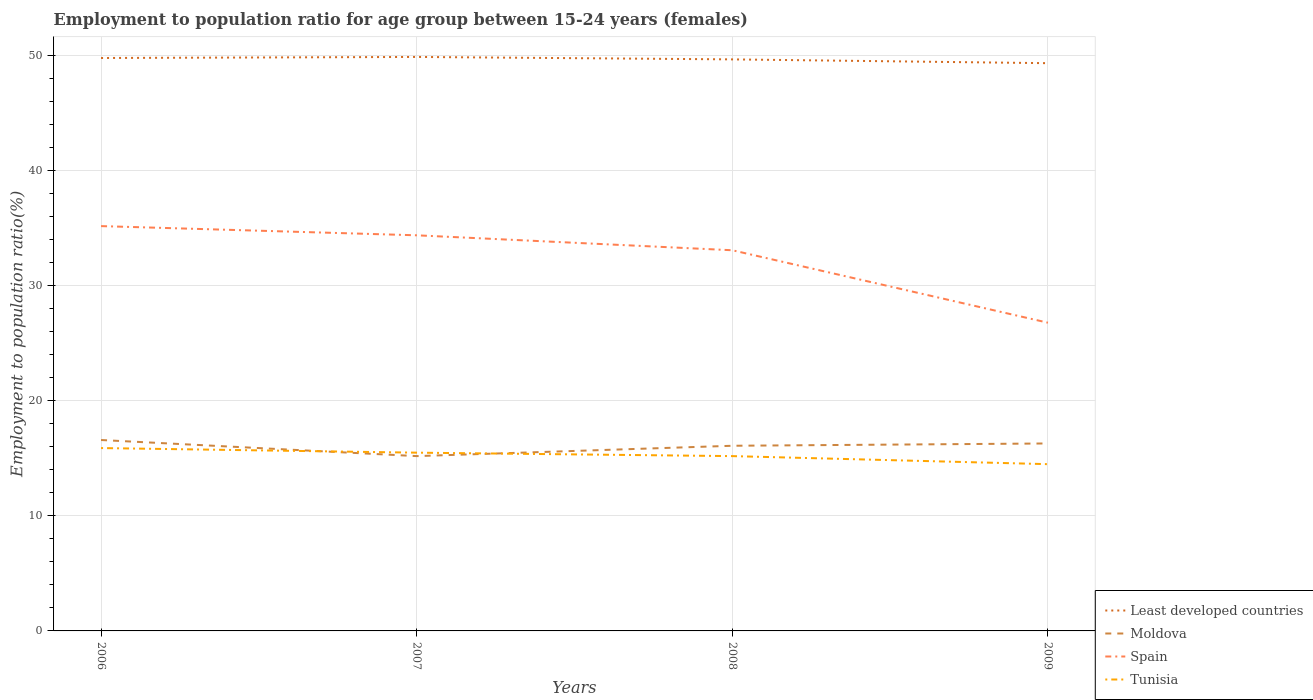Does the line corresponding to Spain intersect with the line corresponding to Tunisia?
Offer a very short reply. No. Is the number of lines equal to the number of legend labels?
Offer a very short reply. Yes. Across all years, what is the maximum employment to population ratio in Spain?
Provide a succinct answer. 26.8. What is the total employment to population ratio in Least developed countries in the graph?
Give a very brief answer. 0.45. What is the difference between the highest and the second highest employment to population ratio in Moldova?
Give a very brief answer. 1.4. What is the difference between the highest and the lowest employment to population ratio in Moldova?
Your response must be concise. 3. Is the employment to population ratio in Tunisia strictly greater than the employment to population ratio in Spain over the years?
Your answer should be very brief. Yes. How many lines are there?
Ensure brevity in your answer.  4. How many years are there in the graph?
Provide a short and direct response. 4. Are the values on the major ticks of Y-axis written in scientific E-notation?
Give a very brief answer. No. Does the graph contain any zero values?
Offer a terse response. No. Does the graph contain grids?
Offer a very short reply. Yes. What is the title of the graph?
Your answer should be very brief. Employment to population ratio for age group between 15-24 years (females). Does "OECD members" appear as one of the legend labels in the graph?
Offer a very short reply. No. What is the label or title of the X-axis?
Your answer should be very brief. Years. What is the label or title of the Y-axis?
Your answer should be compact. Employment to population ratio(%). What is the Employment to population ratio(%) of Least developed countries in 2006?
Keep it short and to the point. 49.82. What is the Employment to population ratio(%) of Moldova in 2006?
Make the answer very short. 16.6. What is the Employment to population ratio(%) in Spain in 2006?
Offer a very short reply. 35.2. What is the Employment to population ratio(%) of Tunisia in 2006?
Your response must be concise. 15.9. What is the Employment to population ratio(%) in Least developed countries in 2007?
Provide a short and direct response. 49.91. What is the Employment to population ratio(%) of Moldova in 2007?
Make the answer very short. 15.2. What is the Employment to population ratio(%) in Spain in 2007?
Your answer should be very brief. 34.4. What is the Employment to population ratio(%) of Tunisia in 2007?
Your answer should be very brief. 15.5. What is the Employment to population ratio(%) of Least developed countries in 2008?
Your answer should be compact. 49.7. What is the Employment to population ratio(%) of Moldova in 2008?
Your response must be concise. 16.1. What is the Employment to population ratio(%) of Spain in 2008?
Your answer should be very brief. 33.1. What is the Employment to population ratio(%) of Tunisia in 2008?
Give a very brief answer. 15.2. What is the Employment to population ratio(%) in Least developed countries in 2009?
Ensure brevity in your answer.  49.37. What is the Employment to population ratio(%) in Moldova in 2009?
Offer a terse response. 16.3. What is the Employment to population ratio(%) of Spain in 2009?
Give a very brief answer. 26.8. What is the Employment to population ratio(%) in Tunisia in 2009?
Keep it short and to the point. 14.5. Across all years, what is the maximum Employment to population ratio(%) of Least developed countries?
Your answer should be very brief. 49.91. Across all years, what is the maximum Employment to population ratio(%) in Moldova?
Keep it short and to the point. 16.6. Across all years, what is the maximum Employment to population ratio(%) of Spain?
Your answer should be very brief. 35.2. Across all years, what is the maximum Employment to population ratio(%) of Tunisia?
Provide a short and direct response. 15.9. Across all years, what is the minimum Employment to population ratio(%) of Least developed countries?
Make the answer very short. 49.37. Across all years, what is the minimum Employment to population ratio(%) of Moldova?
Your answer should be very brief. 15.2. Across all years, what is the minimum Employment to population ratio(%) of Spain?
Ensure brevity in your answer.  26.8. Across all years, what is the minimum Employment to population ratio(%) in Tunisia?
Give a very brief answer. 14.5. What is the total Employment to population ratio(%) of Least developed countries in the graph?
Provide a short and direct response. 198.79. What is the total Employment to population ratio(%) in Moldova in the graph?
Provide a succinct answer. 64.2. What is the total Employment to population ratio(%) of Spain in the graph?
Offer a terse response. 129.5. What is the total Employment to population ratio(%) in Tunisia in the graph?
Provide a succinct answer. 61.1. What is the difference between the Employment to population ratio(%) of Least developed countries in 2006 and that in 2007?
Your answer should be very brief. -0.09. What is the difference between the Employment to population ratio(%) in Moldova in 2006 and that in 2007?
Your answer should be compact. 1.4. What is the difference between the Employment to population ratio(%) of Least developed countries in 2006 and that in 2008?
Your answer should be very brief. 0.12. What is the difference between the Employment to population ratio(%) of Tunisia in 2006 and that in 2008?
Offer a very short reply. 0.7. What is the difference between the Employment to population ratio(%) in Least developed countries in 2006 and that in 2009?
Keep it short and to the point. 0.45. What is the difference between the Employment to population ratio(%) of Moldova in 2006 and that in 2009?
Keep it short and to the point. 0.3. What is the difference between the Employment to population ratio(%) in Spain in 2006 and that in 2009?
Provide a short and direct response. 8.4. What is the difference between the Employment to population ratio(%) of Least developed countries in 2007 and that in 2008?
Provide a short and direct response. 0.21. What is the difference between the Employment to population ratio(%) in Moldova in 2007 and that in 2008?
Keep it short and to the point. -0.9. What is the difference between the Employment to population ratio(%) in Spain in 2007 and that in 2008?
Make the answer very short. 1.3. What is the difference between the Employment to population ratio(%) in Least developed countries in 2007 and that in 2009?
Keep it short and to the point. 0.54. What is the difference between the Employment to population ratio(%) in Moldova in 2007 and that in 2009?
Keep it short and to the point. -1.1. What is the difference between the Employment to population ratio(%) in Spain in 2007 and that in 2009?
Offer a very short reply. 7.6. What is the difference between the Employment to population ratio(%) in Tunisia in 2007 and that in 2009?
Your answer should be compact. 1. What is the difference between the Employment to population ratio(%) of Least developed countries in 2008 and that in 2009?
Make the answer very short. 0.33. What is the difference between the Employment to population ratio(%) of Tunisia in 2008 and that in 2009?
Offer a very short reply. 0.7. What is the difference between the Employment to population ratio(%) of Least developed countries in 2006 and the Employment to population ratio(%) of Moldova in 2007?
Provide a succinct answer. 34.62. What is the difference between the Employment to population ratio(%) in Least developed countries in 2006 and the Employment to population ratio(%) in Spain in 2007?
Offer a very short reply. 15.42. What is the difference between the Employment to population ratio(%) of Least developed countries in 2006 and the Employment to population ratio(%) of Tunisia in 2007?
Give a very brief answer. 34.32. What is the difference between the Employment to population ratio(%) of Moldova in 2006 and the Employment to population ratio(%) of Spain in 2007?
Your response must be concise. -17.8. What is the difference between the Employment to population ratio(%) of Moldova in 2006 and the Employment to population ratio(%) of Tunisia in 2007?
Your answer should be compact. 1.1. What is the difference between the Employment to population ratio(%) in Spain in 2006 and the Employment to population ratio(%) in Tunisia in 2007?
Offer a terse response. 19.7. What is the difference between the Employment to population ratio(%) in Least developed countries in 2006 and the Employment to population ratio(%) in Moldova in 2008?
Your response must be concise. 33.72. What is the difference between the Employment to population ratio(%) of Least developed countries in 2006 and the Employment to population ratio(%) of Spain in 2008?
Provide a succinct answer. 16.72. What is the difference between the Employment to population ratio(%) of Least developed countries in 2006 and the Employment to population ratio(%) of Tunisia in 2008?
Provide a short and direct response. 34.62. What is the difference between the Employment to population ratio(%) of Moldova in 2006 and the Employment to population ratio(%) of Spain in 2008?
Your answer should be compact. -16.5. What is the difference between the Employment to population ratio(%) of Spain in 2006 and the Employment to population ratio(%) of Tunisia in 2008?
Your answer should be compact. 20. What is the difference between the Employment to population ratio(%) in Least developed countries in 2006 and the Employment to population ratio(%) in Moldova in 2009?
Keep it short and to the point. 33.52. What is the difference between the Employment to population ratio(%) in Least developed countries in 2006 and the Employment to population ratio(%) in Spain in 2009?
Your answer should be very brief. 23.02. What is the difference between the Employment to population ratio(%) of Least developed countries in 2006 and the Employment to population ratio(%) of Tunisia in 2009?
Your response must be concise. 35.32. What is the difference between the Employment to population ratio(%) in Moldova in 2006 and the Employment to population ratio(%) in Spain in 2009?
Make the answer very short. -10.2. What is the difference between the Employment to population ratio(%) of Moldova in 2006 and the Employment to population ratio(%) of Tunisia in 2009?
Ensure brevity in your answer.  2.1. What is the difference between the Employment to population ratio(%) in Spain in 2006 and the Employment to population ratio(%) in Tunisia in 2009?
Your response must be concise. 20.7. What is the difference between the Employment to population ratio(%) of Least developed countries in 2007 and the Employment to population ratio(%) of Moldova in 2008?
Make the answer very short. 33.81. What is the difference between the Employment to population ratio(%) in Least developed countries in 2007 and the Employment to population ratio(%) in Spain in 2008?
Ensure brevity in your answer.  16.81. What is the difference between the Employment to population ratio(%) of Least developed countries in 2007 and the Employment to population ratio(%) of Tunisia in 2008?
Your response must be concise. 34.71. What is the difference between the Employment to population ratio(%) of Moldova in 2007 and the Employment to population ratio(%) of Spain in 2008?
Your answer should be very brief. -17.9. What is the difference between the Employment to population ratio(%) of Least developed countries in 2007 and the Employment to population ratio(%) of Moldova in 2009?
Offer a terse response. 33.61. What is the difference between the Employment to population ratio(%) of Least developed countries in 2007 and the Employment to population ratio(%) of Spain in 2009?
Your response must be concise. 23.11. What is the difference between the Employment to population ratio(%) in Least developed countries in 2007 and the Employment to population ratio(%) in Tunisia in 2009?
Your answer should be very brief. 35.41. What is the difference between the Employment to population ratio(%) in Moldova in 2007 and the Employment to population ratio(%) in Tunisia in 2009?
Give a very brief answer. 0.7. What is the difference between the Employment to population ratio(%) of Spain in 2007 and the Employment to population ratio(%) of Tunisia in 2009?
Your answer should be very brief. 19.9. What is the difference between the Employment to population ratio(%) in Least developed countries in 2008 and the Employment to population ratio(%) in Moldova in 2009?
Your answer should be compact. 33.4. What is the difference between the Employment to population ratio(%) of Least developed countries in 2008 and the Employment to population ratio(%) of Spain in 2009?
Offer a very short reply. 22.9. What is the difference between the Employment to population ratio(%) of Least developed countries in 2008 and the Employment to population ratio(%) of Tunisia in 2009?
Offer a very short reply. 35.2. What is the difference between the Employment to population ratio(%) of Spain in 2008 and the Employment to population ratio(%) of Tunisia in 2009?
Provide a succinct answer. 18.6. What is the average Employment to population ratio(%) in Least developed countries per year?
Ensure brevity in your answer.  49.7. What is the average Employment to population ratio(%) of Moldova per year?
Provide a succinct answer. 16.05. What is the average Employment to population ratio(%) in Spain per year?
Your answer should be very brief. 32.38. What is the average Employment to population ratio(%) in Tunisia per year?
Offer a terse response. 15.28. In the year 2006, what is the difference between the Employment to population ratio(%) of Least developed countries and Employment to population ratio(%) of Moldova?
Give a very brief answer. 33.22. In the year 2006, what is the difference between the Employment to population ratio(%) in Least developed countries and Employment to population ratio(%) in Spain?
Ensure brevity in your answer.  14.62. In the year 2006, what is the difference between the Employment to population ratio(%) in Least developed countries and Employment to population ratio(%) in Tunisia?
Ensure brevity in your answer.  33.92. In the year 2006, what is the difference between the Employment to population ratio(%) in Moldova and Employment to population ratio(%) in Spain?
Offer a very short reply. -18.6. In the year 2006, what is the difference between the Employment to population ratio(%) of Moldova and Employment to population ratio(%) of Tunisia?
Your answer should be very brief. 0.7. In the year 2006, what is the difference between the Employment to population ratio(%) in Spain and Employment to population ratio(%) in Tunisia?
Your answer should be compact. 19.3. In the year 2007, what is the difference between the Employment to population ratio(%) of Least developed countries and Employment to population ratio(%) of Moldova?
Ensure brevity in your answer.  34.71. In the year 2007, what is the difference between the Employment to population ratio(%) of Least developed countries and Employment to population ratio(%) of Spain?
Give a very brief answer. 15.51. In the year 2007, what is the difference between the Employment to population ratio(%) of Least developed countries and Employment to population ratio(%) of Tunisia?
Your response must be concise. 34.41. In the year 2007, what is the difference between the Employment to population ratio(%) of Moldova and Employment to population ratio(%) of Spain?
Your response must be concise. -19.2. In the year 2008, what is the difference between the Employment to population ratio(%) of Least developed countries and Employment to population ratio(%) of Moldova?
Make the answer very short. 33.6. In the year 2008, what is the difference between the Employment to population ratio(%) in Least developed countries and Employment to population ratio(%) in Spain?
Give a very brief answer. 16.6. In the year 2008, what is the difference between the Employment to population ratio(%) in Least developed countries and Employment to population ratio(%) in Tunisia?
Offer a very short reply. 34.5. In the year 2009, what is the difference between the Employment to population ratio(%) in Least developed countries and Employment to population ratio(%) in Moldova?
Provide a short and direct response. 33.07. In the year 2009, what is the difference between the Employment to population ratio(%) in Least developed countries and Employment to population ratio(%) in Spain?
Your response must be concise. 22.57. In the year 2009, what is the difference between the Employment to population ratio(%) of Least developed countries and Employment to population ratio(%) of Tunisia?
Provide a succinct answer. 34.87. In the year 2009, what is the difference between the Employment to population ratio(%) in Spain and Employment to population ratio(%) in Tunisia?
Provide a short and direct response. 12.3. What is the ratio of the Employment to population ratio(%) of Moldova in 2006 to that in 2007?
Offer a terse response. 1.09. What is the ratio of the Employment to population ratio(%) of Spain in 2006 to that in 2007?
Offer a terse response. 1.02. What is the ratio of the Employment to population ratio(%) in Tunisia in 2006 to that in 2007?
Your answer should be very brief. 1.03. What is the ratio of the Employment to population ratio(%) in Least developed countries in 2006 to that in 2008?
Offer a very short reply. 1. What is the ratio of the Employment to population ratio(%) of Moldova in 2006 to that in 2008?
Keep it short and to the point. 1.03. What is the ratio of the Employment to population ratio(%) of Spain in 2006 to that in 2008?
Give a very brief answer. 1.06. What is the ratio of the Employment to population ratio(%) in Tunisia in 2006 to that in 2008?
Provide a short and direct response. 1.05. What is the ratio of the Employment to population ratio(%) of Least developed countries in 2006 to that in 2009?
Your answer should be very brief. 1.01. What is the ratio of the Employment to population ratio(%) in Moldova in 2006 to that in 2009?
Your answer should be very brief. 1.02. What is the ratio of the Employment to population ratio(%) in Spain in 2006 to that in 2009?
Your answer should be compact. 1.31. What is the ratio of the Employment to population ratio(%) of Tunisia in 2006 to that in 2009?
Offer a very short reply. 1.1. What is the ratio of the Employment to population ratio(%) of Least developed countries in 2007 to that in 2008?
Give a very brief answer. 1. What is the ratio of the Employment to population ratio(%) of Moldova in 2007 to that in 2008?
Your answer should be compact. 0.94. What is the ratio of the Employment to population ratio(%) in Spain in 2007 to that in 2008?
Provide a short and direct response. 1.04. What is the ratio of the Employment to population ratio(%) in Tunisia in 2007 to that in 2008?
Provide a short and direct response. 1.02. What is the ratio of the Employment to population ratio(%) in Least developed countries in 2007 to that in 2009?
Your answer should be compact. 1.01. What is the ratio of the Employment to population ratio(%) of Moldova in 2007 to that in 2009?
Offer a terse response. 0.93. What is the ratio of the Employment to population ratio(%) of Spain in 2007 to that in 2009?
Your response must be concise. 1.28. What is the ratio of the Employment to population ratio(%) in Tunisia in 2007 to that in 2009?
Provide a succinct answer. 1.07. What is the ratio of the Employment to population ratio(%) in Spain in 2008 to that in 2009?
Make the answer very short. 1.24. What is the ratio of the Employment to population ratio(%) of Tunisia in 2008 to that in 2009?
Provide a short and direct response. 1.05. What is the difference between the highest and the second highest Employment to population ratio(%) in Least developed countries?
Offer a very short reply. 0.09. What is the difference between the highest and the second highest Employment to population ratio(%) of Moldova?
Make the answer very short. 0.3. What is the difference between the highest and the lowest Employment to population ratio(%) in Least developed countries?
Keep it short and to the point. 0.54. What is the difference between the highest and the lowest Employment to population ratio(%) in Moldova?
Keep it short and to the point. 1.4. What is the difference between the highest and the lowest Employment to population ratio(%) of Spain?
Provide a succinct answer. 8.4. 